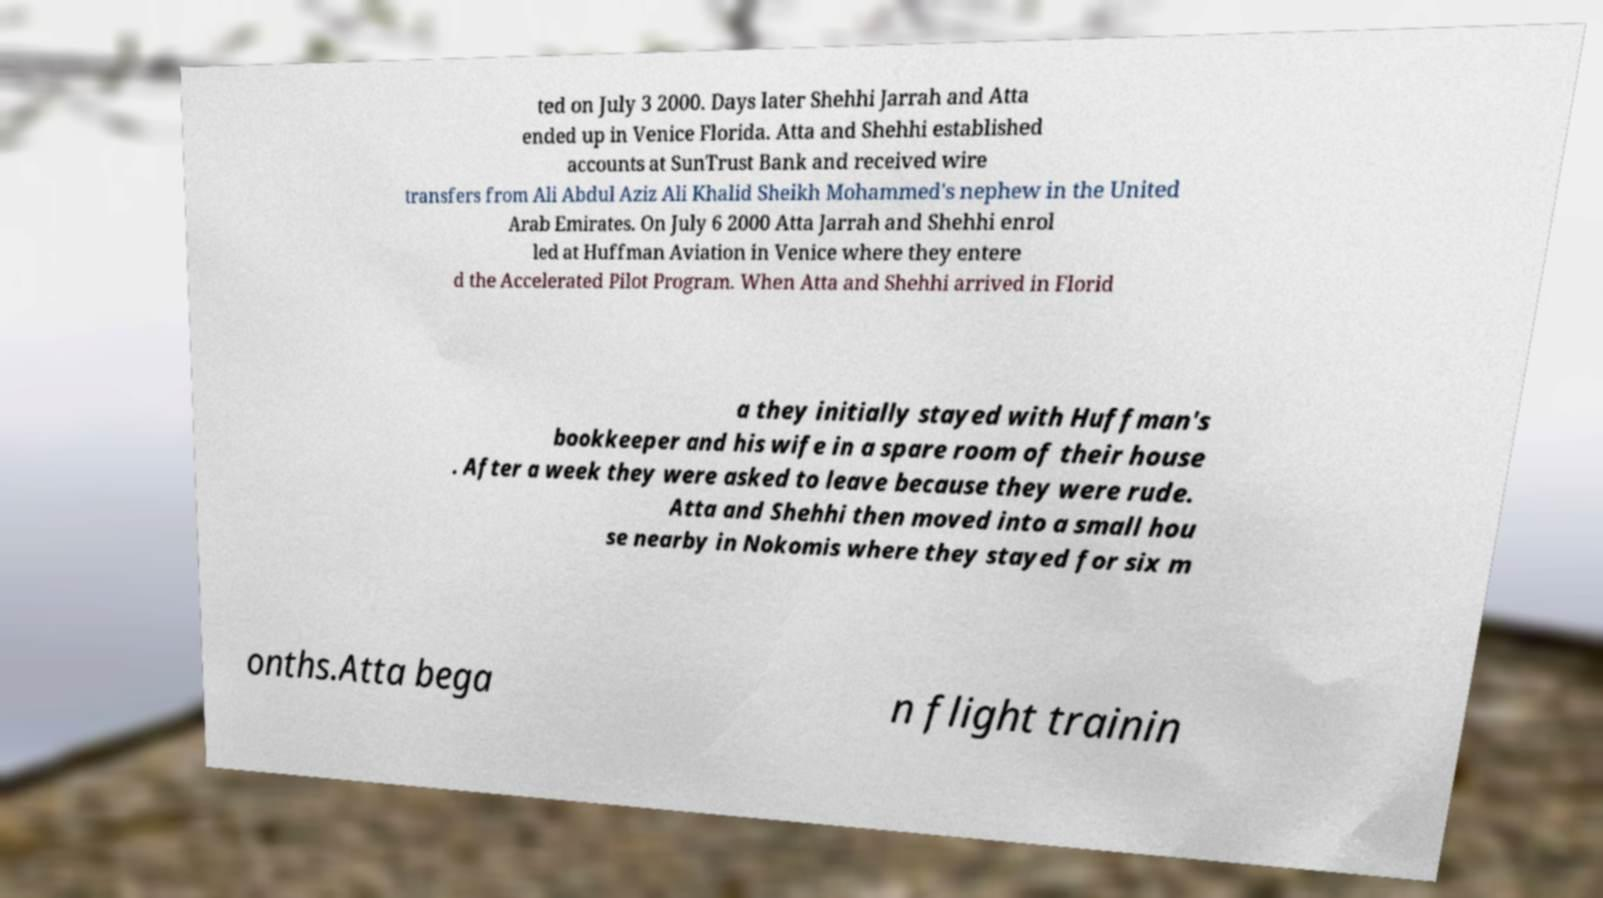I need the written content from this picture converted into text. Can you do that? ted on July 3 2000. Days later Shehhi Jarrah and Atta ended up in Venice Florida. Atta and Shehhi established accounts at SunTrust Bank and received wire transfers from Ali Abdul Aziz Ali Khalid Sheikh Mohammed's nephew in the United Arab Emirates. On July 6 2000 Atta Jarrah and Shehhi enrol led at Huffman Aviation in Venice where they entere d the Accelerated Pilot Program. When Atta and Shehhi arrived in Florid a they initially stayed with Huffman's bookkeeper and his wife in a spare room of their house . After a week they were asked to leave because they were rude. Atta and Shehhi then moved into a small hou se nearby in Nokomis where they stayed for six m onths.Atta bega n flight trainin 